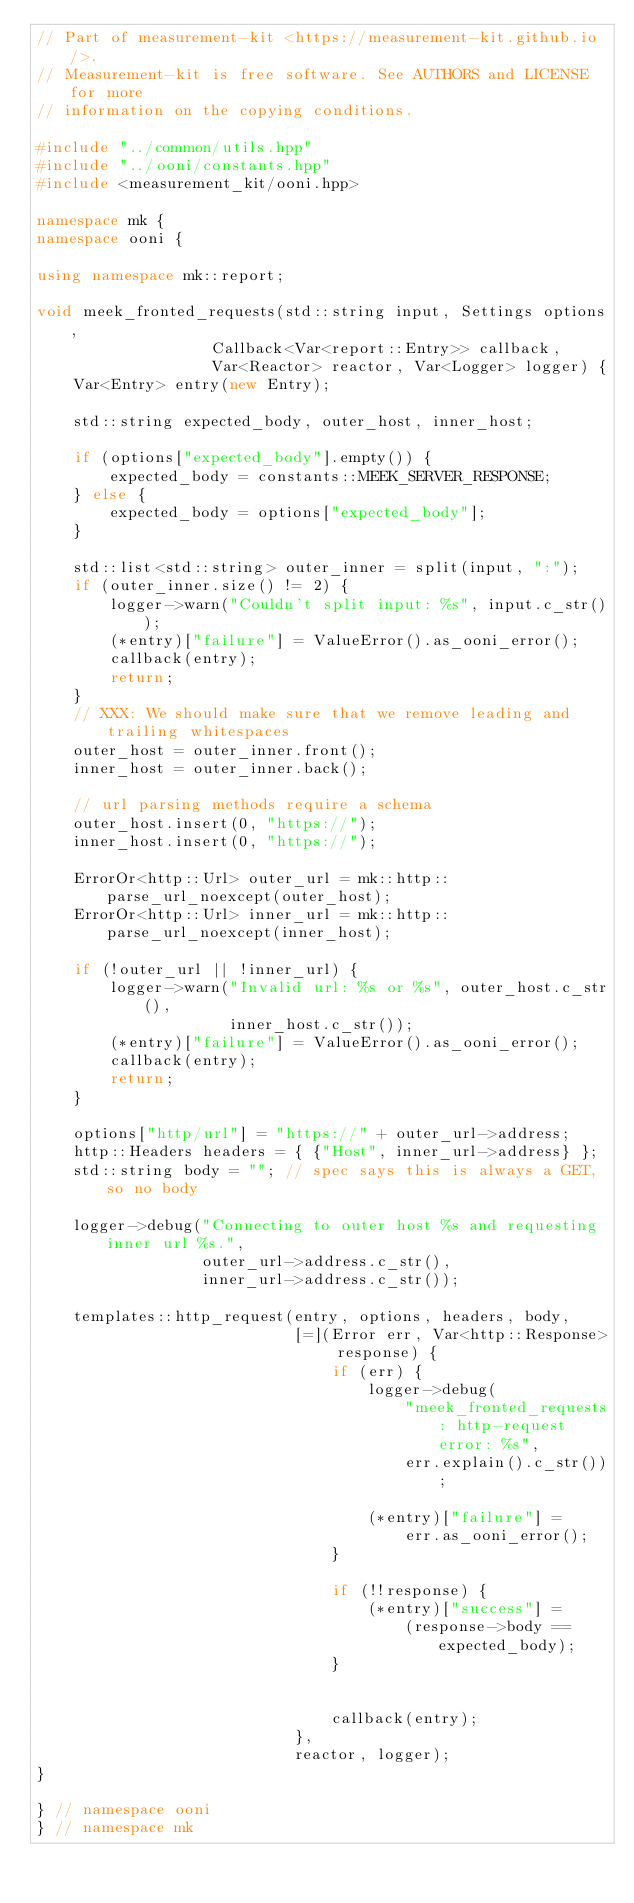Convert code to text. <code><loc_0><loc_0><loc_500><loc_500><_C++_>// Part of measurement-kit <https://measurement-kit.github.io/>.
// Measurement-kit is free software. See AUTHORS and LICENSE for more
// information on the copying conditions.

#include "../common/utils.hpp"
#include "../ooni/constants.hpp"
#include <measurement_kit/ooni.hpp>

namespace mk {
namespace ooni {

using namespace mk::report;

void meek_fronted_requests(std::string input, Settings options,
                   Callback<Var<report::Entry>> callback,
                   Var<Reactor> reactor, Var<Logger> logger) {
    Var<Entry> entry(new Entry);

    std::string expected_body, outer_host, inner_host;

    if (options["expected_body"].empty()) {
        expected_body = constants::MEEK_SERVER_RESPONSE;
    } else {
        expected_body = options["expected_body"];
    }

    std::list<std::string> outer_inner = split(input, ":");
    if (outer_inner.size() != 2) {
        logger->warn("Couldn't split input: %s", input.c_str());
        (*entry)["failure"] = ValueError().as_ooni_error();
        callback(entry);
        return;
    }
    // XXX: We should make sure that we remove leading and trailing whitespaces
    outer_host = outer_inner.front();
    inner_host = outer_inner.back();

    // url parsing methods require a schema
    outer_host.insert(0, "https://");
    inner_host.insert(0, "https://");

    ErrorOr<http::Url> outer_url = mk::http::parse_url_noexcept(outer_host);
    ErrorOr<http::Url> inner_url = mk::http::parse_url_noexcept(inner_host);

    if (!outer_url || !inner_url) {
        logger->warn("Invalid url: %s or %s", outer_host.c_str(),
                     inner_host.c_str());
        (*entry)["failure"] = ValueError().as_ooni_error();
        callback(entry);
        return;
    }

    options["http/url"] = "https://" + outer_url->address;
    http::Headers headers = { {"Host", inner_url->address} };
    std::string body = ""; // spec says this is always a GET, so no body

    logger->debug("Connecting to outer host %s and requesting inner url %s.",
                  outer_url->address.c_str(),
                  inner_url->address.c_str());

    templates::http_request(entry, options, headers, body,
                            [=](Error err, Var<http::Response> response) {
                                if (err) {
                                    logger->debug(
                                        "meek_fronted_requests: http-request error: %s",
                                        err.explain().c_str());

                                    (*entry)["failure"] =
                                        err.as_ooni_error();
                                }

                                if (!!response) {
                                    (*entry)["success"] =
                                        (response->body == expected_body);
                                }


                                callback(entry);
                            },
                            reactor, logger);
}

} // namespace ooni
} // namespace mk
</code> 